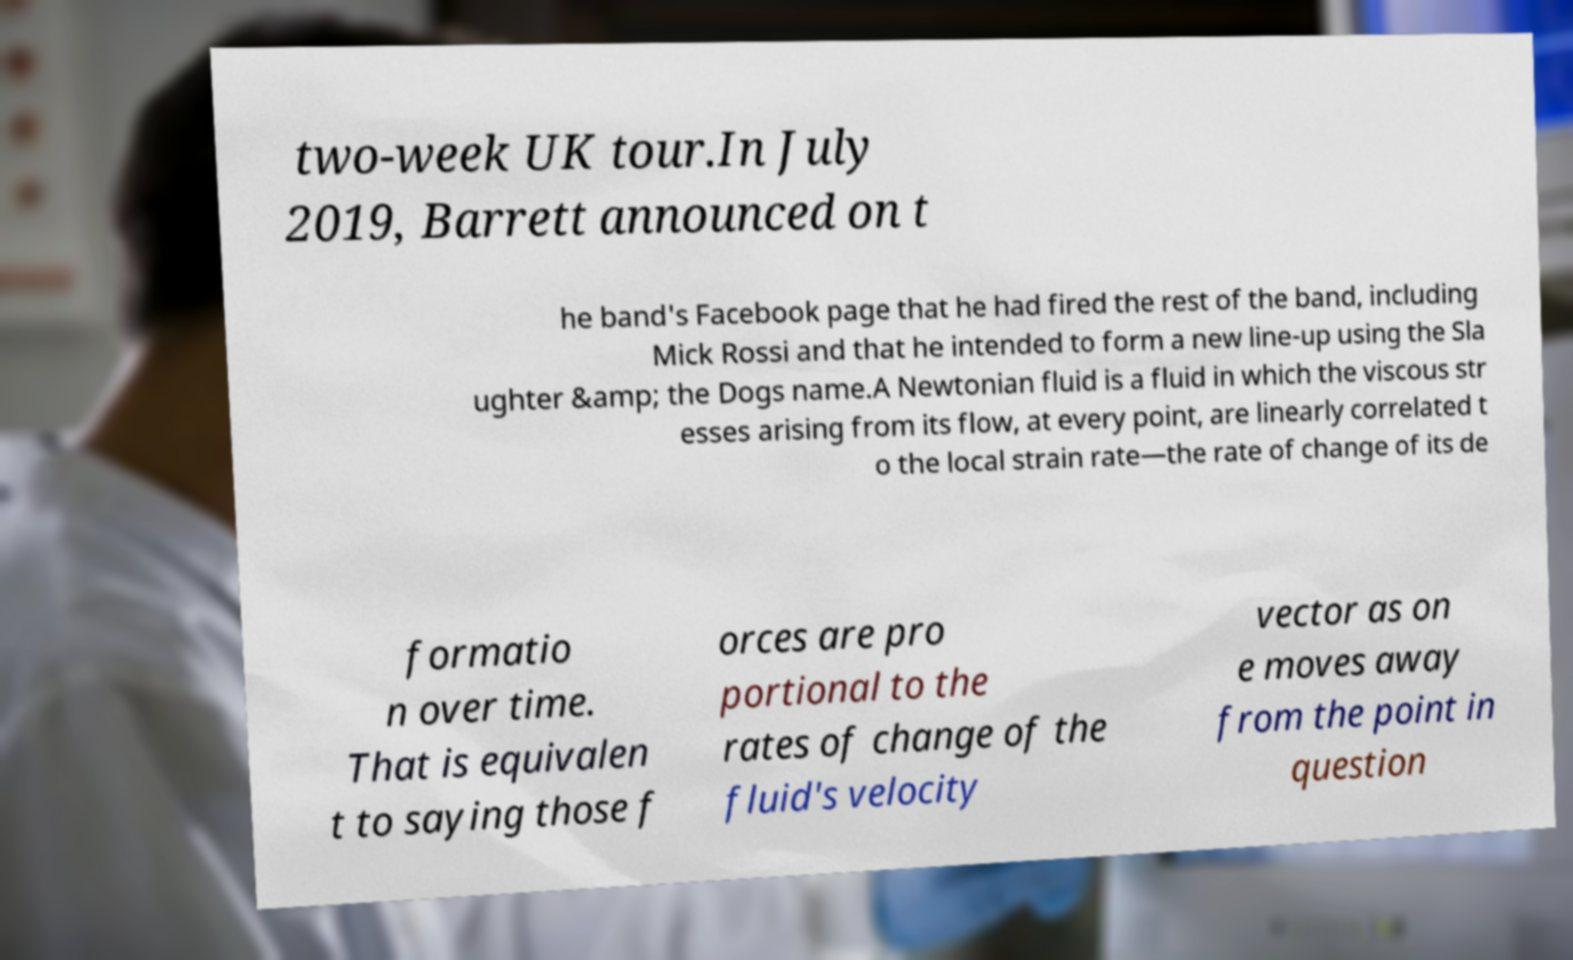Please read and relay the text visible in this image. What does it say? two-week UK tour.In July 2019, Barrett announced on t he band's Facebook page that he had fired the rest of the band, including Mick Rossi and that he intended to form a new line-up using the Sla ughter &amp; the Dogs name.A Newtonian fluid is a fluid in which the viscous str esses arising from its flow, at every point, are linearly correlated t o the local strain rate—the rate of change of its de formatio n over time. That is equivalen t to saying those f orces are pro portional to the rates of change of the fluid's velocity vector as on e moves away from the point in question 